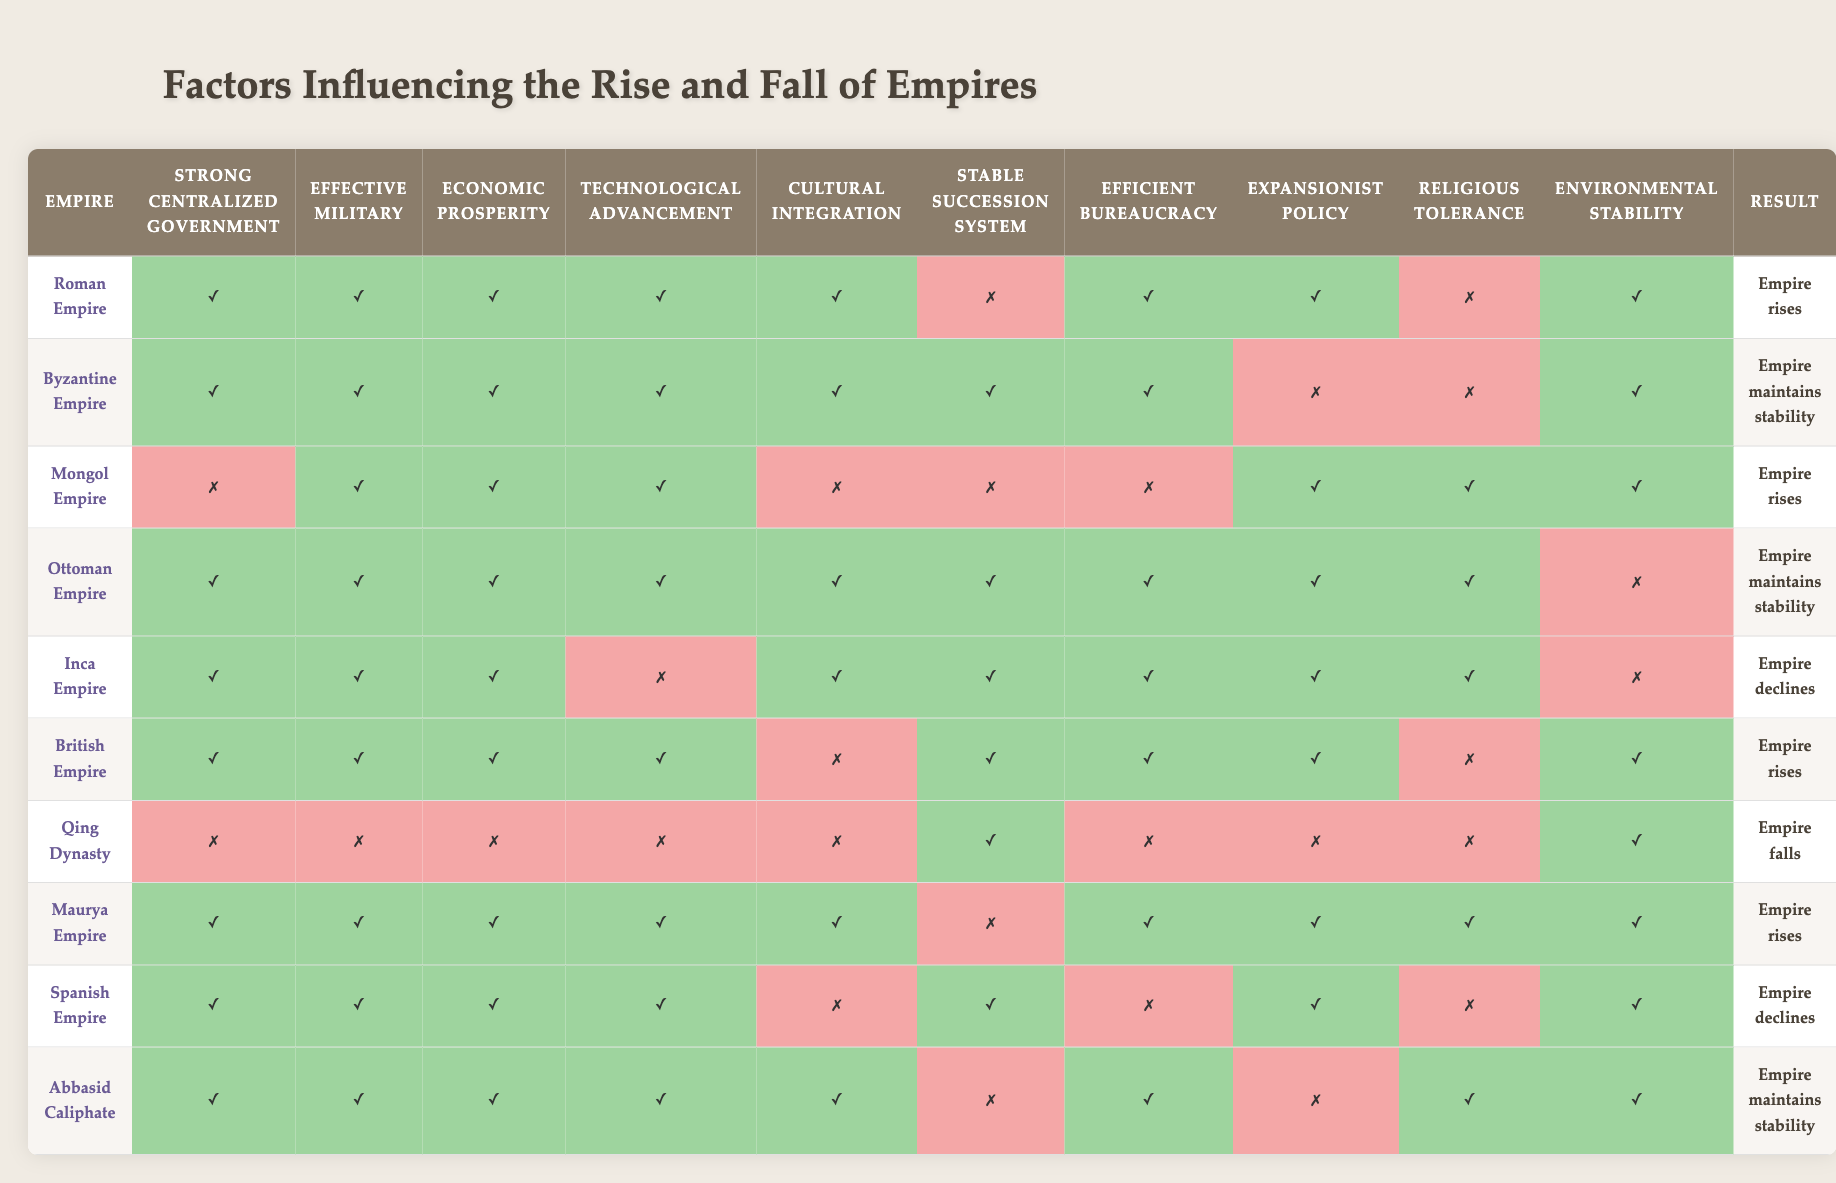What percentage of empires in the table rose compared to those that fell? There are 10 empires total. The Roman Empire, Mongol Empire, British Empire, Maurya Empire, and Ottoman Empire rose, which is 5 empires. The Qing Dynasty represents the only empire that fell, making it 1 empire. To find the percentage of empires that rose, we calculate (5/10) * 100 = 50%.
Answer: 50% Which empire maintained stability with a strong centralized government, effective military, and efficient bureaucracy? The Byzantine Empire meets all these criteria as it has true values for strong centralized government, effective military, and efficient bureaucracy while maintaining stability.
Answer: Byzantine Empire Did the Inca Empire have a stable succession system? In the table, the Inca Empire is marked with false for the stable succession system. This indicates that it did not have one.
Answer: No Which empires both rose and had religious tolerance? The Mongol Empire and the British Empire are both marked true for rising and having religious tolerance. Step by step: The Mongol Empire rose and has true for religious tolerance; the British Empire is in the same criteria.
Answer: Mongol Empire, British Empire What is the relationship between environmental stability and the rise or fall of empires in this table? To understand the relationship, we analyze the table for empires that rose or fell while having true or false flags in environmental stability. The Roman, Mongol, British, Maurya Empires rose with varying environmental stability, while the Qing Dynasty fell despite having true for environmental stability. Thus, there's no clear relationship established, suggesting other factors might have had a stronger influence.
Answer: No clear relationship How many empires had both technological advancement and economic prosperity but declined? The Spanish Empire is the only one that meets both conditions; it is marked true for economic prosperity and technological advancement yet is declining.
Answer: 1 Did any empires maintain stability without cultural integration? Yes, the Byzantine Empire and Abbasid Caliphate achieved stability but was marked false for cultural integration. We find both have true values for other stability criteria.
Answer: Yes What were the key conditions for the rise of the British Empire based on the table? The British Empire had true values in conditions: strong centralized government, effective military, economic prosperity, technological advancement, efficient bureaucracy, expansionist policy, and true for environmental stability. All these factors contributed to its rise.
Answer: Strong centralized government, effective military, economic prosperity, technological advancement, efficient bureaucracy, expansionist policy, environmental stability 